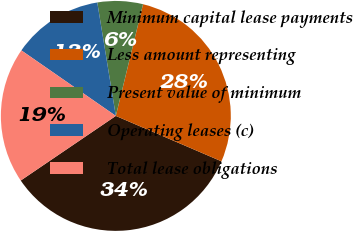Convert chart. <chart><loc_0><loc_0><loc_500><loc_500><pie_chart><fcel>Minimum capital lease payments<fcel>Less amount representing<fcel>Present value of minimum<fcel>Operating leases (c)<fcel>Total lease obligations<nl><fcel>34.04%<fcel>27.66%<fcel>6.38%<fcel>12.77%<fcel>19.15%<nl></chart> 